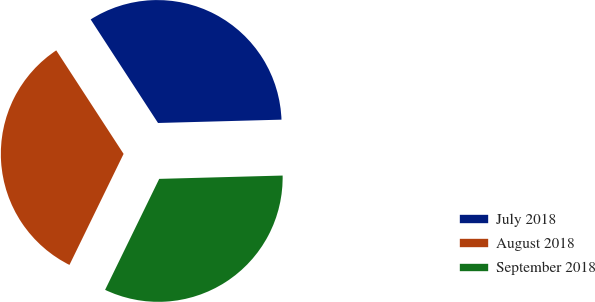Convert chart to OTSL. <chart><loc_0><loc_0><loc_500><loc_500><pie_chart><fcel>July 2018<fcel>August 2018<fcel>September 2018<nl><fcel>33.75%<fcel>33.6%<fcel>32.65%<nl></chart> 